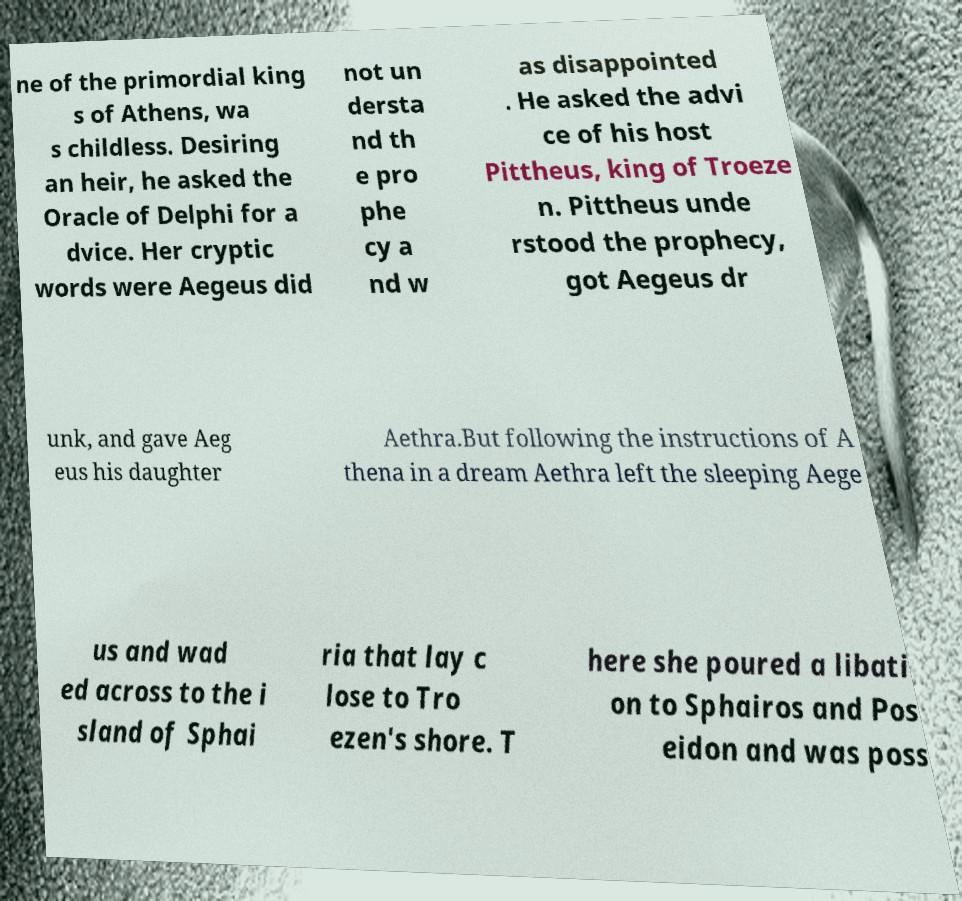Please read and relay the text visible in this image. What does it say? ne of the primordial king s of Athens, wa s childless. Desiring an heir, he asked the Oracle of Delphi for a dvice. Her cryptic words were Aegeus did not un dersta nd th e pro phe cy a nd w as disappointed . He asked the advi ce of his host Pittheus, king of Troeze n. Pittheus unde rstood the prophecy, got Aegeus dr unk, and gave Aeg eus his daughter Aethra.But following the instructions of A thena in a dream Aethra left the sleeping Aege us and wad ed across to the i sland of Sphai ria that lay c lose to Tro ezen's shore. T here she poured a libati on to Sphairos and Pos eidon and was poss 